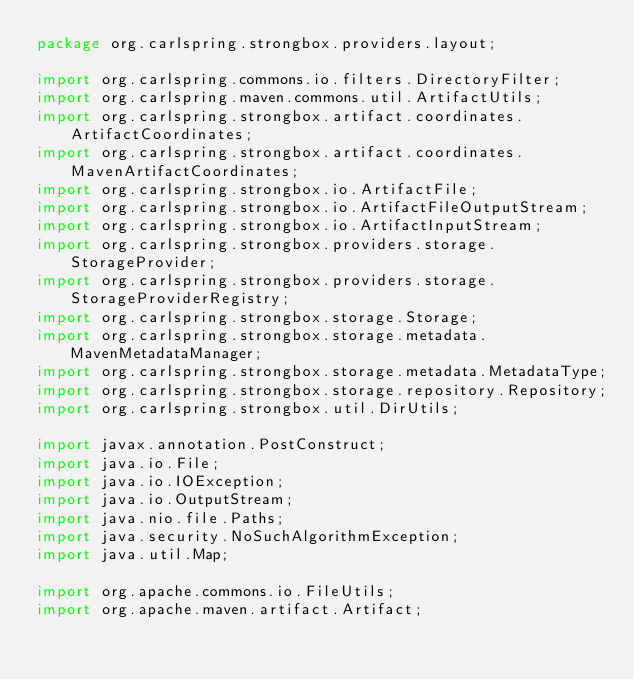Convert code to text. <code><loc_0><loc_0><loc_500><loc_500><_Java_>package org.carlspring.strongbox.providers.layout;

import org.carlspring.commons.io.filters.DirectoryFilter;
import org.carlspring.maven.commons.util.ArtifactUtils;
import org.carlspring.strongbox.artifact.coordinates.ArtifactCoordinates;
import org.carlspring.strongbox.artifact.coordinates.MavenArtifactCoordinates;
import org.carlspring.strongbox.io.ArtifactFile;
import org.carlspring.strongbox.io.ArtifactFileOutputStream;
import org.carlspring.strongbox.io.ArtifactInputStream;
import org.carlspring.strongbox.providers.storage.StorageProvider;
import org.carlspring.strongbox.providers.storage.StorageProviderRegistry;
import org.carlspring.strongbox.storage.Storage;
import org.carlspring.strongbox.storage.metadata.MavenMetadataManager;
import org.carlspring.strongbox.storage.metadata.MetadataType;
import org.carlspring.strongbox.storage.repository.Repository;
import org.carlspring.strongbox.util.DirUtils;

import javax.annotation.PostConstruct;
import java.io.File;
import java.io.IOException;
import java.io.OutputStream;
import java.nio.file.Paths;
import java.security.NoSuchAlgorithmException;
import java.util.Map;

import org.apache.commons.io.FileUtils;
import org.apache.maven.artifact.Artifact;</code> 